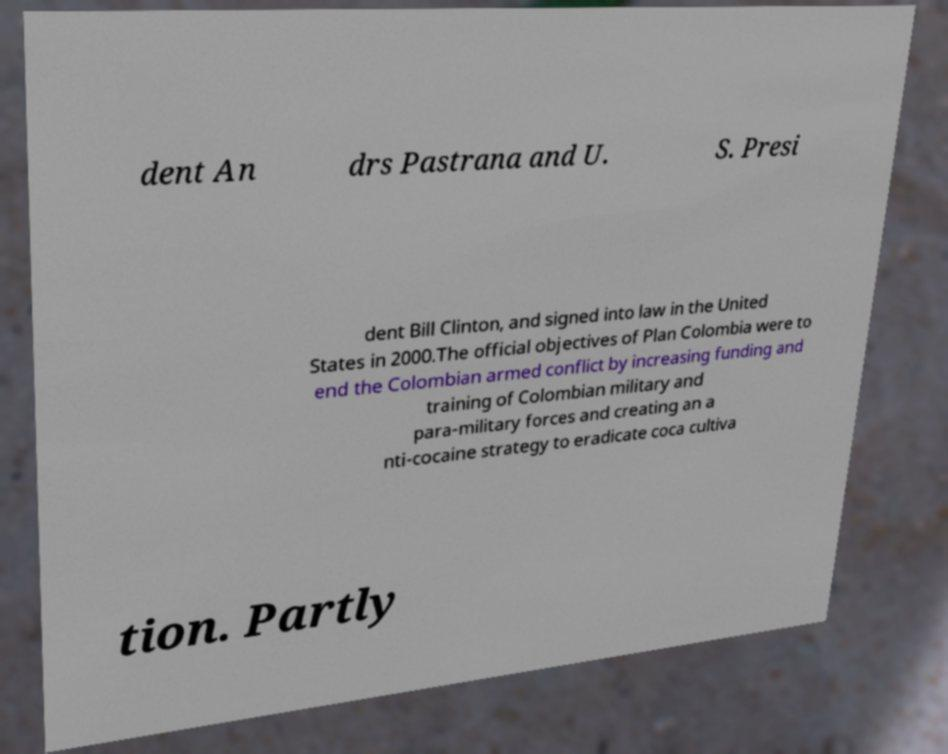Please identify and transcribe the text found in this image. dent An drs Pastrana and U. S. Presi dent Bill Clinton, and signed into law in the United States in 2000.The official objectives of Plan Colombia were to end the Colombian armed conflict by increasing funding and training of Colombian military and para-military forces and creating an a nti-cocaine strategy to eradicate coca cultiva tion. Partly 